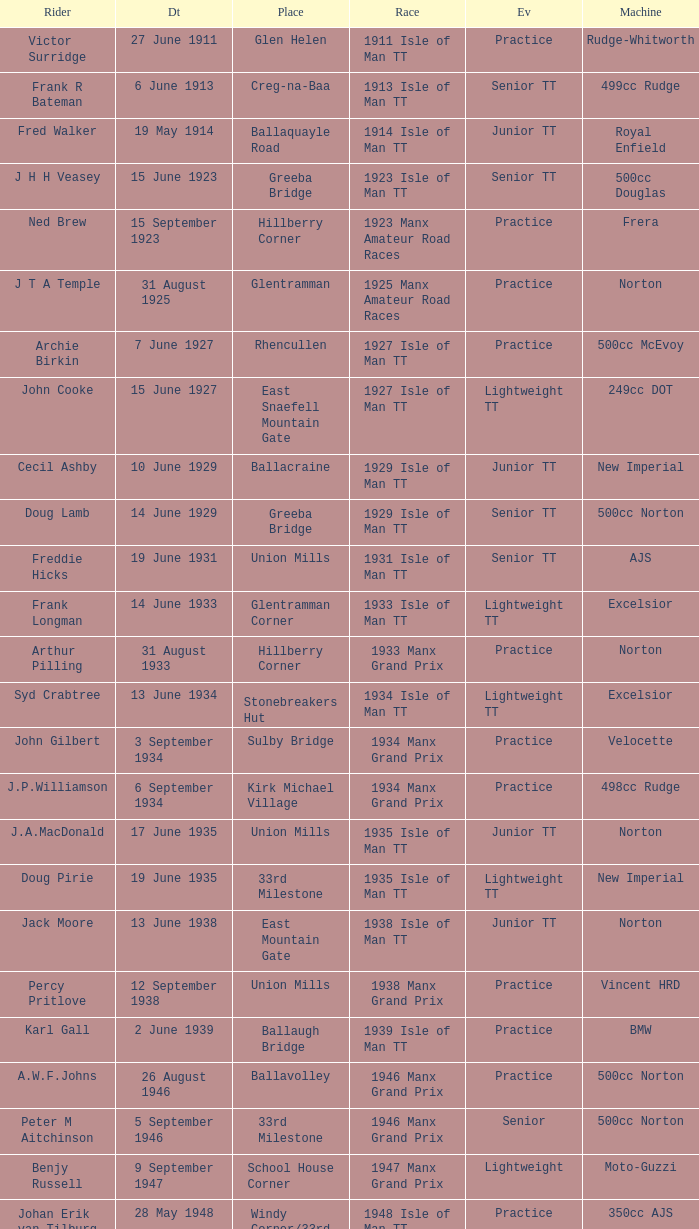What machine did Kenneth E. Herbert ride? 499cc Norton. 